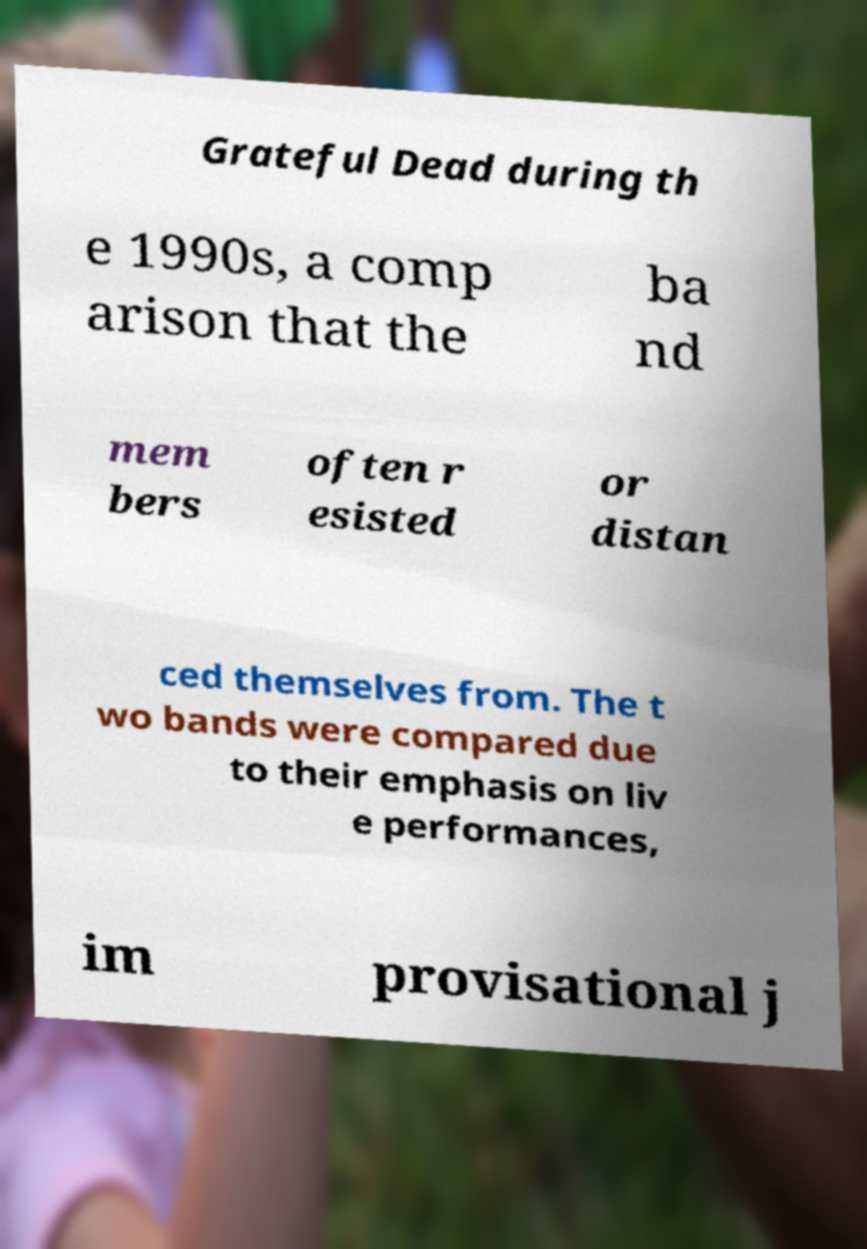Could you extract and type out the text from this image? Grateful Dead during th e 1990s, a comp arison that the ba nd mem bers often r esisted or distan ced themselves from. The t wo bands were compared due to their emphasis on liv e performances, im provisational j 